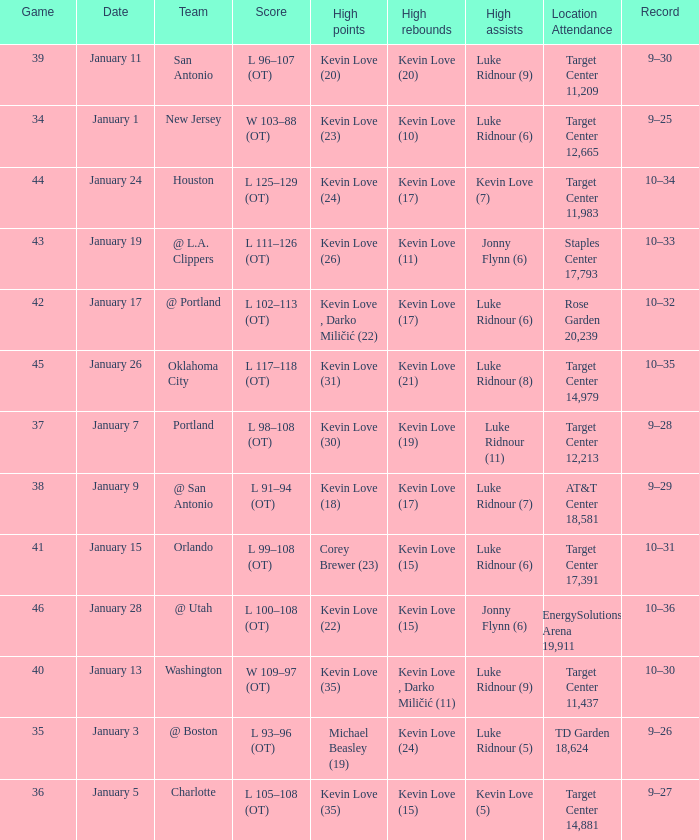When is the event featuring team orlando taking place? January 15. 